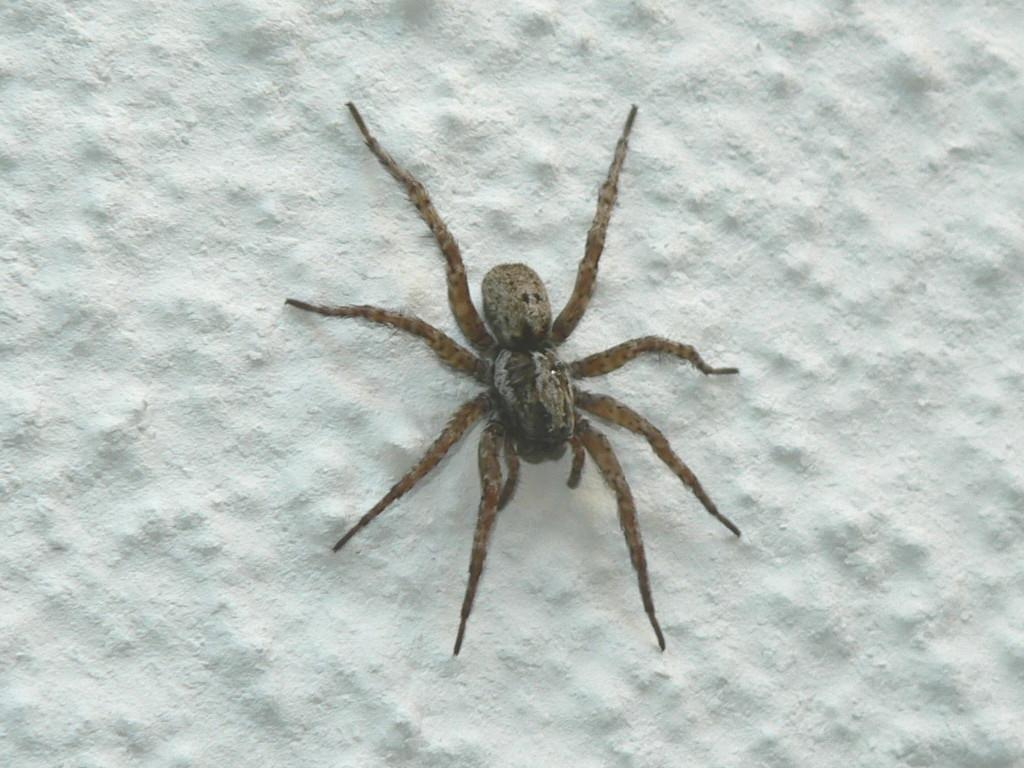What is the main subject of the image? The main subject of the image is a spider. What is the color of the surface on which the spider is located? The spider is on a white surface. What type of toothbrush is the spider using in the image? There is no toothbrush present in the image, and the spider is not using any such object. 